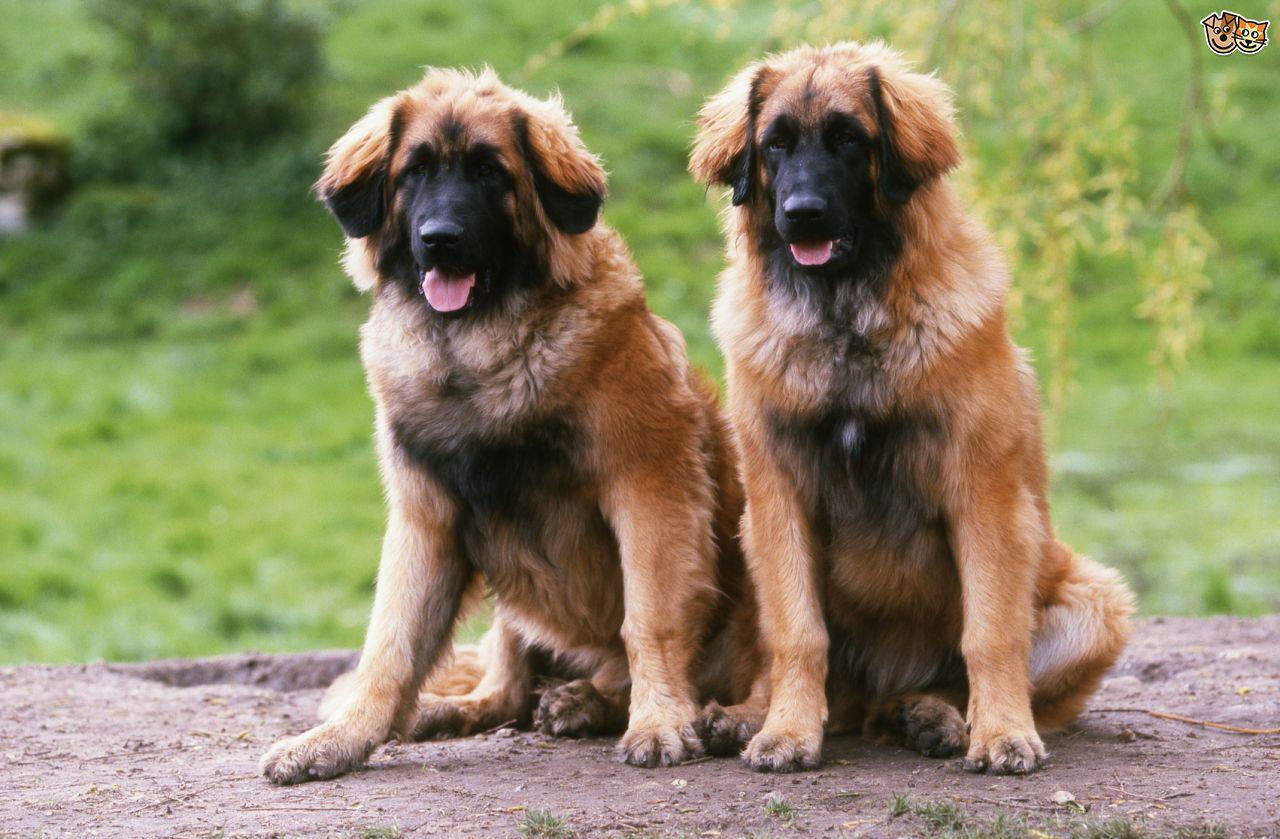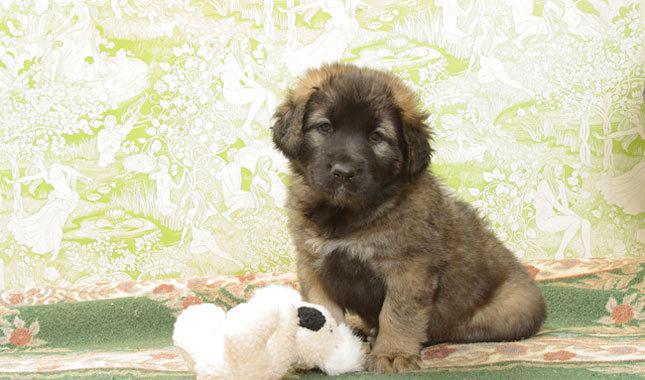The first image is the image on the left, the second image is the image on the right. Given the left and right images, does the statement "A person is standing by a large dog in one image." hold true? Answer yes or no. No. 